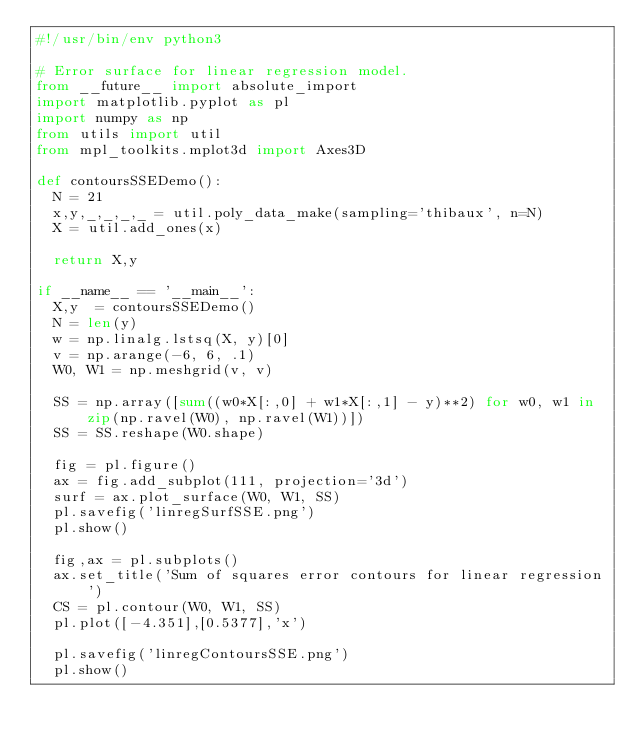Convert code to text. <code><loc_0><loc_0><loc_500><loc_500><_Python_>#!/usr/bin/env python3

# Error surface for linear regression model.
from __future__ import absolute_import
import matplotlib.pyplot as pl
import numpy as np
from utils import util
from mpl_toolkits.mplot3d import Axes3D

def contoursSSEDemo():
  N = 21
  x,y,_,_,_,_ = util.poly_data_make(sampling='thibaux', n=N)
  X = util.add_ones(x)

  return X,y

if __name__ == '__main__':
  X,y  = contoursSSEDemo()
  N = len(y)
  w = np.linalg.lstsq(X, y)[0]
  v = np.arange(-6, 6, .1)
  W0, W1 = np.meshgrid(v, v)

  SS = np.array([sum((w0*X[:,0] + w1*X[:,1] - y)**2) for w0, w1 in zip(np.ravel(W0), np.ravel(W1))])
  SS = SS.reshape(W0.shape)

  fig = pl.figure()
  ax = fig.add_subplot(111, projection='3d')
  surf = ax.plot_surface(W0, W1, SS)
  pl.savefig('linregSurfSSE.png')
  pl.show()

  fig,ax = pl.subplots()
  ax.set_title('Sum of squares error contours for linear regression')
  CS = pl.contour(W0, W1, SS)
  pl.plot([-4.351],[0.5377],'x')

  pl.savefig('linregContoursSSE.png')
  pl.show()
</code> 